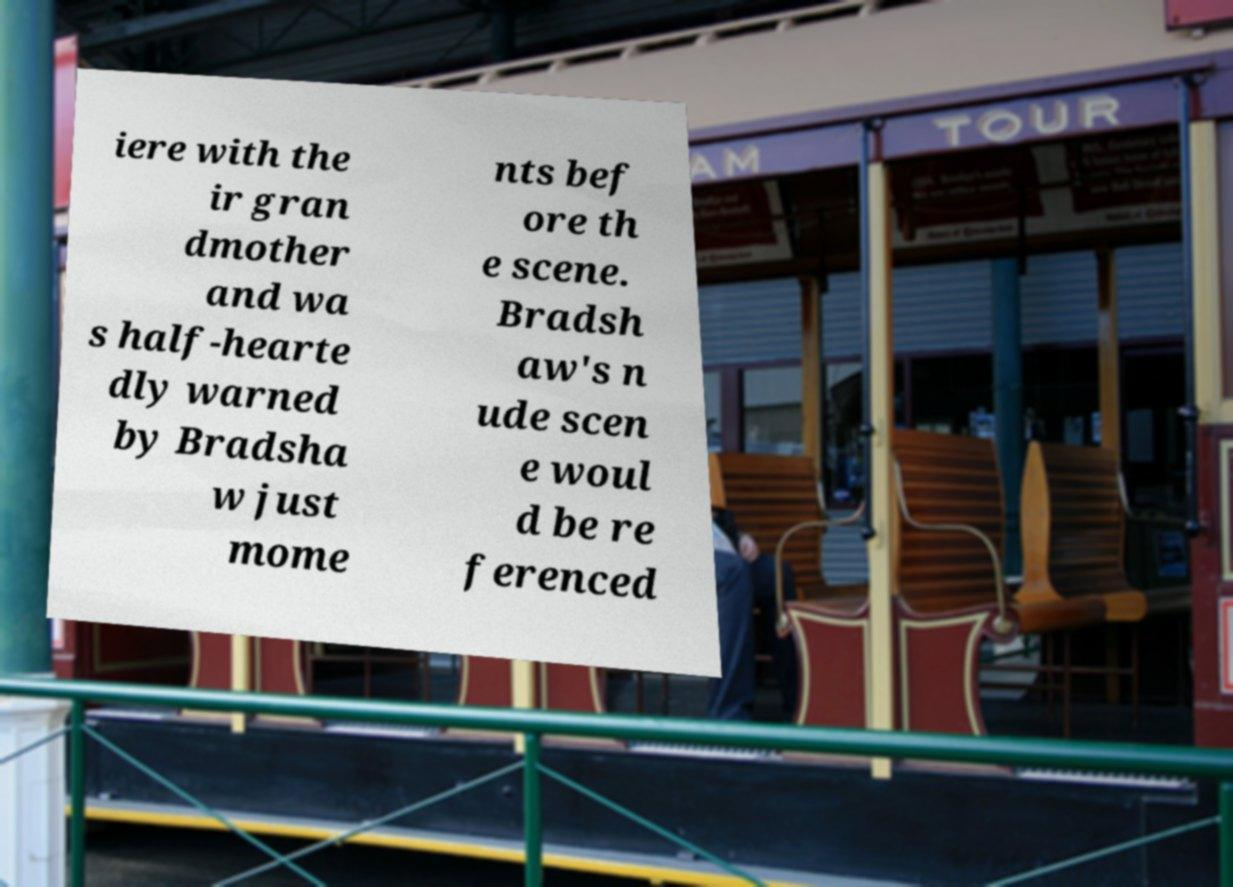Could you extract and type out the text from this image? iere with the ir gran dmother and wa s half-hearte dly warned by Bradsha w just mome nts bef ore th e scene. Bradsh aw's n ude scen e woul d be re ferenced 